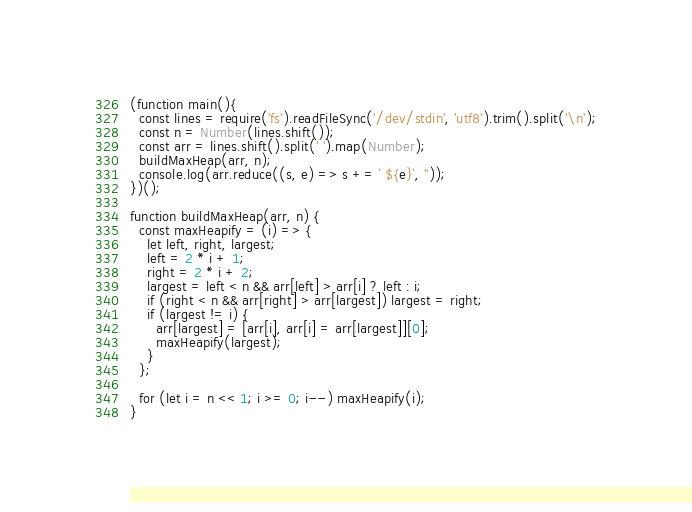Convert code to text. <code><loc_0><loc_0><loc_500><loc_500><_JavaScript_>(function main(){
  const lines = require('fs').readFileSync('/dev/stdin', 'utf8').trim().split('\n');
  const n = Number(lines.shift());
  const arr = lines.shift().split(' ').map(Number);
  buildMaxHeap(arr, n);
  console.log(arr.reduce((s, e) => s += ` ${e}`, ''));
})();

function buildMaxHeap(arr, n) {
  const maxHeapify = (i) => {
    let left, right, largest;
    left = 2 * i + 1;
    right = 2 * i + 2;
    largest = left < n && arr[left] > arr[i] ? left : i;
    if (right < n && arr[right] > arr[largest]) largest = right;
    if (largest != i) {
      arr[largest] = [arr[i], arr[i] = arr[largest]][0];
      maxHeapify(largest);
    }
  };

  for (let i = n << 1; i >= 0; i--) maxHeapify(i);
}

</code> 